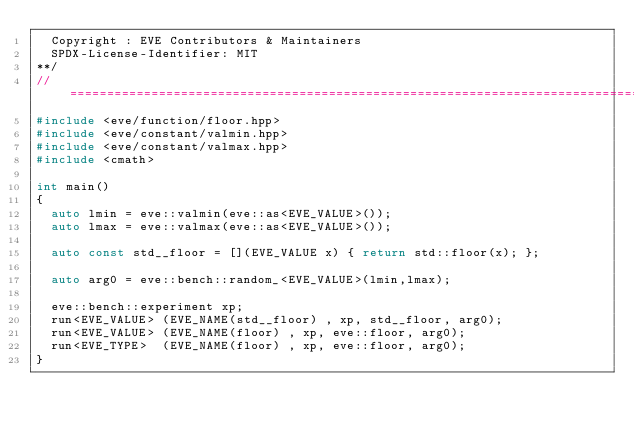Convert code to text. <code><loc_0><loc_0><loc_500><loc_500><_C++_>  Copyright : EVE Contributors & Maintainers
  SPDX-License-Identifier: MIT
**/
//==================================================================================================
#include <eve/function/floor.hpp>
#include <eve/constant/valmin.hpp>
#include <eve/constant/valmax.hpp>
#include <cmath>

int main()
{
  auto lmin = eve::valmin(eve::as<EVE_VALUE>());
  auto lmax = eve::valmax(eve::as<EVE_VALUE>());

  auto const std__floor = [](EVE_VALUE x) { return std::floor(x); };

  auto arg0 = eve::bench::random_<EVE_VALUE>(lmin,lmax);

  eve::bench::experiment xp;
  run<EVE_VALUE> (EVE_NAME(std__floor) , xp, std__floor, arg0);
  run<EVE_VALUE> (EVE_NAME(floor) , xp, eve::floor, arg0);
  run<EVE_TYPE>  (EVE_NAME(floor) , xp, eve::floor, arg0);
}
</code> 